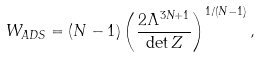<formula> <loc_0><loc_0><loc_500><loc_500>W _ { A D S } = ( N - 1 ) \left ( \frac { 2 \Lambda ^ { 3 N + 1 } } { \det Z } \right ) ^ { 1 / ( N - 1 ) } ,</formula> 